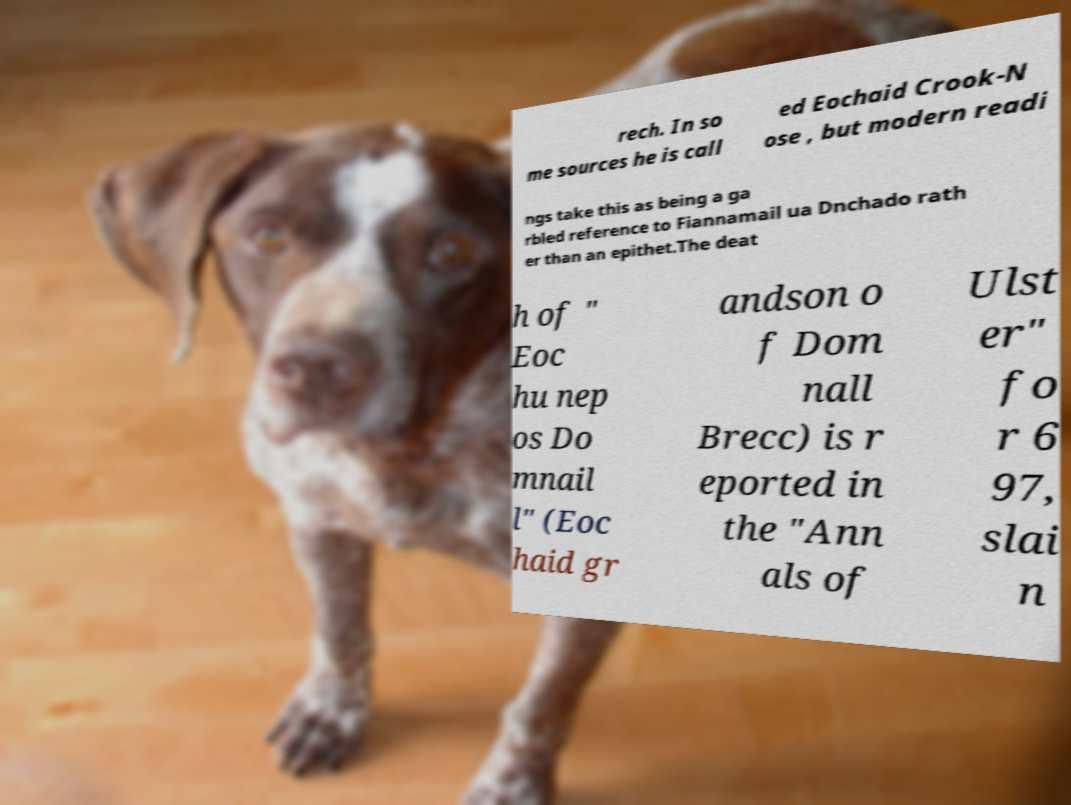Please identify and transcribe the text found in this image. rech. In so me sources he is call ed Eochaid Crook-N ose , but modern readi ngs take this as being a ga rbled reference to Fiannamail ua Dnchado rath er than an epithet.The deat h of " Eoc hu nep os Do mnail l" (Eoc haid gr andson o f Dom nall Brecc) is r eported in the "Ann als of Ulst er" fo r 6 97, slai n 